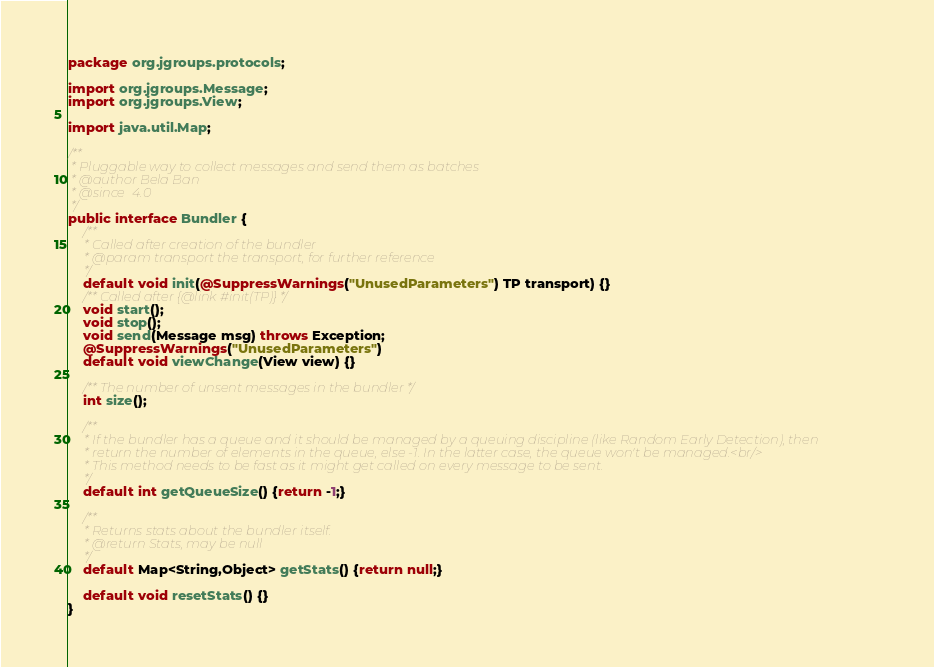Convert code to text. <code><loc_0><loc_0><loc_500><loc_500><_Java_>package org.jgroups.protocols;

import org.jgroups.Message;
import org.jgroups.View;

import java.util.Map;

/**
 * Pluggable way to collect messages and send them as batches
 * @author Bela Ban
 * @since  4.0
 */
public interface Bundler {
    /**
     * Called after creation of the bundler
     * @param transport the transport, for further reference
     */
    default void init(@SuppressWarnings("UnusedParameters") TP transport) {}
    /** Called after {@link #init(TP)} */
    void start();
    void stop();
    void send(Message msg) throws Exception;
    @SuppressWarnings("UnusedParameters")
    default void viewChange(View view) {}

    /** The number of unsent messages in the bundler */
    int size();

    /**
     * If the bundler has a queue and it should be managed by a queuing discipline (like Random Early Detection), then
     * return the number of elements in the queue, else -1. In the latter case, the queue won't be managed.<br/>
     * This method needs to be fast as it might get called on every message to be sent.
     */
    default int getQueueSize() {return -1;}

    /**
     * Returns stats about the bundler itself.
     * @return Stats, may be null
     */
    default Map<String,Object> getStats() {return null;}

    default void resetStats() {}
}
</code> 